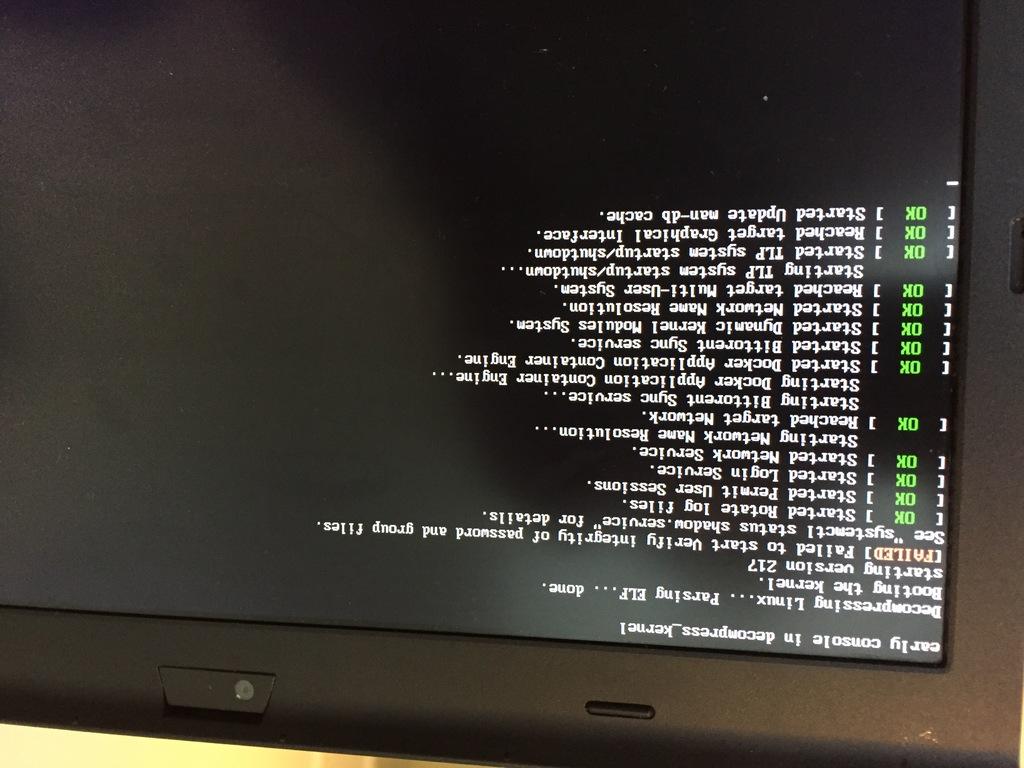What's written in green?
Provide a succinct answer. Ok. 